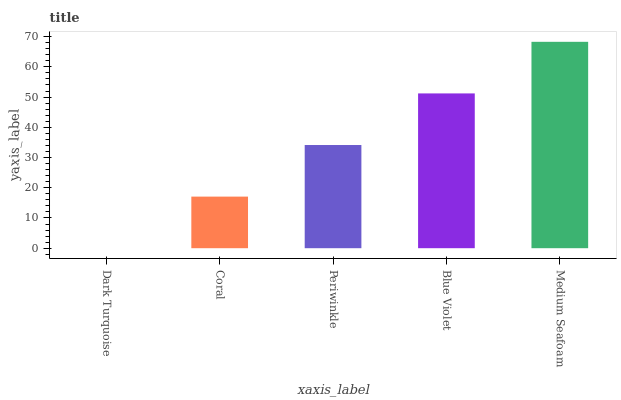Is Dark Turquoise the minimum?
Answer yes or no. Yes. Is Medium Seafoam the maximum?
Answer yes or no. Yes. Is Coral the minimum?
Answer yes or no. No. Is Coral the maximum?
Answer yes or no. No. Is Coral greater than Dark Turquoise?
Answer yes or no. Yes. Is Dark Turquoise less than Coral?
Answer yes or no. Yes. Is Dark Turquoise greater than Coral?
Answer yes or no. No. Is Coral less than Dark Turquoise?
Answer yes or no. No. Is Periwinkle the high median?
Answer yes or no. Yes. Is Periwinkle the low median?
Answer yes or no. Yes. Is Coral the high median?
Answer yes or no. No. Is Medium Seafoam the low median?
Answer yes or no. No. 